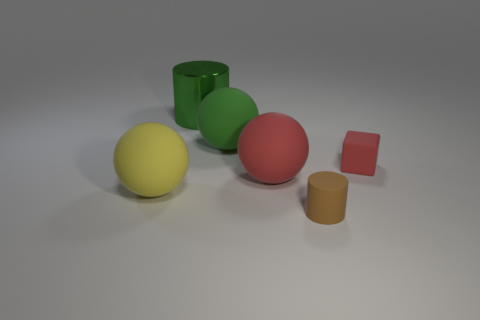What is the size of the rubber ball that is the same color as the tiny block?
Give a very brief answer. Large. What material is the ball that is the same color as the metal thing?
Make the answer very short. Rubber. Are there more large red rubber spheres right of the tiny rubber cylinder than big rubber things behind the green metal cylinder?
Offer a terse response. No. Is there a big green thing made of the same material as the large yellow object?
Give a very brief answer. Yes. Does the block have the same color as the large cylinder?
Provide a succinct answer. No. What material is the large sphere that is behind the yellow thing and left of the large red ball?
Offer a terse response. Rubber. What color is the metal cylinder?
Make the answer very short. Green. What number of other small rubber things have the same shape as the brown object?
Provide a short and direct response. 0. Does the object left of the large metallic cylinder have the same material as the cylinder behind the tiny red rubber block?
Provide a succinct answer. No. What size is the green cylinder that is on the left side of the small matte thing in front of the large yellow rubber object?
Offer a terse response. Large. 